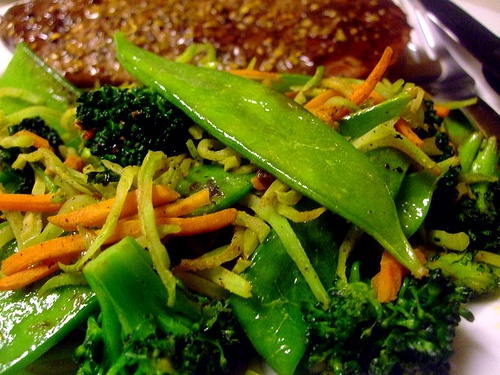Describe the objects in this image and their specific colors. I can see broccoli in gray, black, darkgreen, and green tones, broccoli in gray, black, darkgreen, and olive tones, broccoli in gray, black, darkgreen, olive, and green tones, carrot in gray, red, orange, and maroon tones, and carrot in gray, orange, red, and maroon tones in this image. 